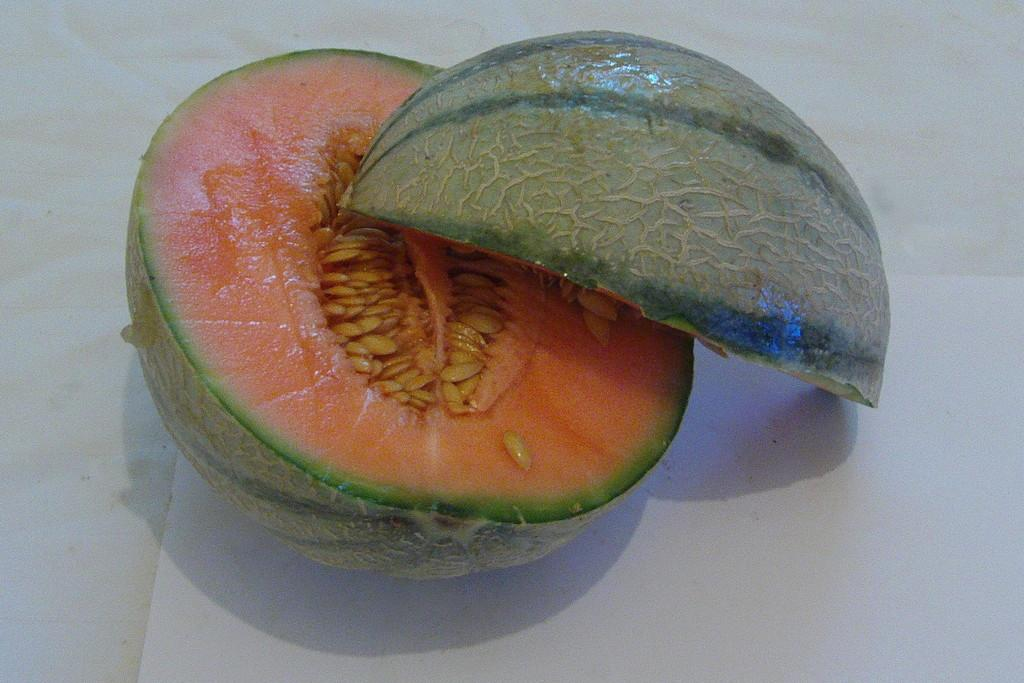How many pieces of fruit are visible in the image? There are two pieces of fruit in the image. Where are the pieces of fruit located? The fruit is on a surface. What color is the moon in the image? There is no moon present in the image. What type of quiver can be seen holding the fruit in the image? There is no quiver present in the image; the fruit is simply on a surface. 